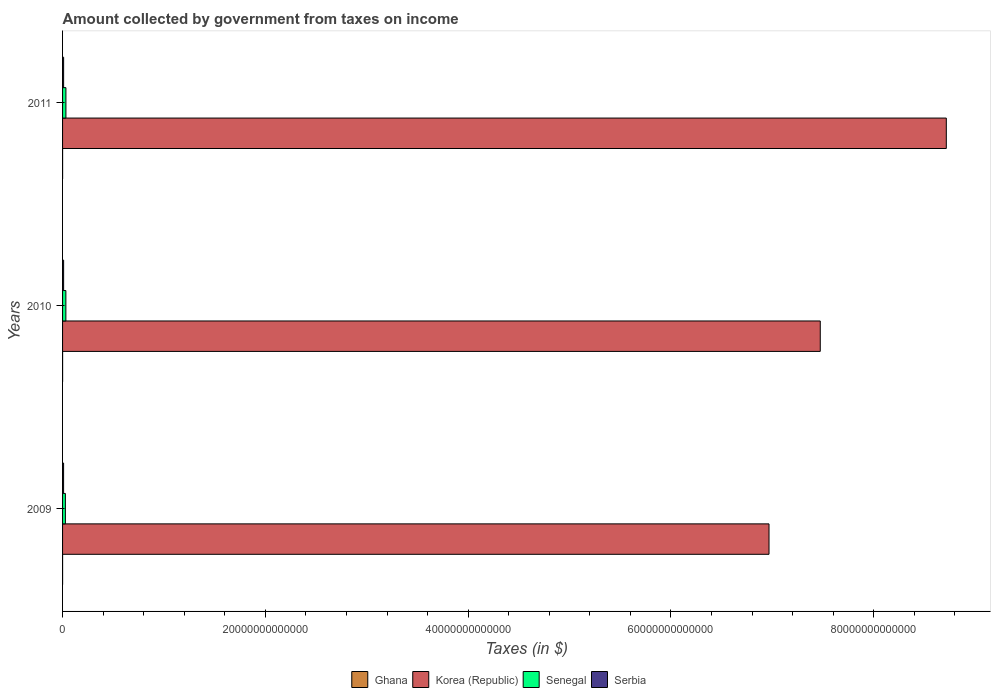How many different coloured bars are there?
Make the answer very short. 4. Are the number of bars per tick equal to the number of legend labels?
Offer a very short reply. Yes. How many bars are there on the 3rd tick from the bottom?
Give a very brief answer. 4. What is the label of the 3rd group of bars from the top?
Your answer should be compact. 2009. In how many cases, is the number of bars for a given year not equal to the number of legend labels?
Provide a short and direct response. 0. What is the amount collected by government from taxes on income in Korea (Republic) in 2010?
Keep it short and to the point. 7.47e+13. Across all years, what is the maximum amount collected by government from taxes on income in Serbia?
Provide a short and direct response. 1.05e+11. Across all years, what is the minimum amount collected by government from taxes on income in Korea (Republic)?
Give a very brief answer. 6.97e+13. What is the total amount collected by government from taxes on income in Ghana in the graph?
Your answer should be very brief. 6.93e+09. What is the difference between the amount collected by government from taxes on income in Ghana in 2010 and that in 2011?
Keep it short and to the point. -9.98e+08. What is the difference between the amount collected by government from taxes on income in Senegal in 2010 and the amount collected by government from taxes on income in Ghana in 2011?
Offer a very short reply. 3.23e+11. What is the average amount collected by government from taxes on income in Senegal per year?
Your response must be concise. 3.12e+11. In the year 2010, what is the difference between the amount collected by government from taxes on income in Ghana and amount collected by government from taxes on income in Serbia?
Offer a terse response. -1.03e+11. What is the ratio of the amount collected by government from taxes on income in Ghana in 2009 to that in 2011?
Your response must be concise. 0.48. Is the amount collected by government from taxes on income in Korea (Republic) in 2010 less than that in 2011?
Provide a succinct answer. Yes. Is the difference between the amount collected by government from taxes on income in Ghana in 2009 and 2011 greater than the difference between the amount collected by government from taxes on income in Serbia in 2009 and 2011?
Provide a succinct answer. Yes. What is the difference between the highest and the second highest amount collected by government from taxes on income in Senegal?
Provide a succinct answer. 4.64e+09. What is the difference between the highest and the lowest amount collected by government from taxes on income in Serbia?
Provide a succinct answer. 4.26e+09. In how many years, is the amount collected by government from taxes on income in Senegal greater than the average amount collected by government from taxes on income in Senegal taken over all years?
Provide a short and direct response. 2. Is it the case that in every year, the sum of the amount collected by government from taxes on income in Serbia and amount collected by government from taxes on income in Ghana is greater than the sum of amount collected by government from taxes on income in Korea (Republic) and amount collected by government from taxes on income in Senegal?
Your response must be concise. No. What does the 1st bar from the top in 2010 represents?
Keep it short and to the point. Serbia. What does the 2nd bar from the bottom in 2011 represents?
Your answer should be very brief. Korea (Republic). Is it the case that in every year, the sum of the amount collected by government from taxes on income in Senegal and amount collected by government from taxes on income in Serbia is greater than the amount collected by government from taxes on income in Korea (Republic)?
Provide a short and direct response. No. Are all the bars in the graph horizontal?
Your answer should be very brief. Yes. How many years are there in the graph?
Offer a terse response. 3. What is the difference between two consecutive major ticks on the X-axis?
Offer a terse response. 2.00e+13. Does the graph contain grids?
Make the answer very short. No. Where does the legend appear in the graph?
Provide a succinct answer. Bottom center. How many legend labels are there?
Make the answer very short. 4. How are the legend labels stacked?
Your answer should be very brief. Horizontal. What is the title of the graph?
Keep it short and to the point. Amount collected by government from taxes on income. Does "South Sudan" appear as one of the legend labels in the graph?
Your answer should be very brief. No. What is the label or title of the X-axis?
Give a very brief answer. Taxes (in $). What is the Taxes (in $) in Ghana in 2009?
Provide a short and direct response. 1.54e+09. What is the Taxes (in $) of Korea (Republic) in 2009?
Provide a succinct answer. 6.97e+13. What is the Taxes (in $) in Senegal in 2009?
Offer a terse response. 2.78e+11. What is the Taxes (in $) of Serbia in 2009?
Ensure brevity in your answer.  1.01e+11. What is the Taxes (in $) in Ghana in 2010?
Ensure brevity in your answer.  2.19e+09. What is the Taxes (in $) in Korea (Republic) in 2010?
Make the answer very short. 7.47e+13. What is the Taxes (in $) of Senegal in 2010?
Your answer should be very brief. 3.26e+11. What is the Taxes (in $) of Serbia in 2010?
Give a very brief answer. 1.05e+11. What is the Taxes (in $) in Ghana in 2011?
Provide a short and direct response. 3.19e+09. What is the Taxes (in $) of Korea (Republic) in 2011?
Provide a short and direct response. 8.72e+13. What is the Taxes (in $) in Senegal in 2011?
Your answer should be compact. 3.31e+11. What is the Taxes (in $) in Serbia in 2011?
Your answer should be very brief. 1.04e+11. Across all years, what is the maximum Taxes (in $) in Ghana?
Make the answer very short. 3.19e+09. Across all years, what is the maximum Taxes (in $) of Korea (Republic)?
Provide a succinct answer. 8.72e+13. Across all years, what is the maximum Taxes (in $) in Senegal?
Provide a succinct answer. 3.31e+11. Across all years, what is the maximum Taxes (in $) of Serbia?
Offer a very short reply. 1.05e+11. Across all years, what is the minimum Taxes (in $) of Ghana?
Keep it short and to the point. 1.54e+09. Across all years, what is the minimum Taxes (in $) of Korea (Republic)?
Your answer should be very brief. 6.97e+13. Across all years, what is the minimum Taxes (in $) of Senegal?
Offer a very short reply. 2.78e+11. Across all years, what is the minimum Taxes (in $) in Serbia?
Your answer should be compact. 1.01e+11. What is the total Taxes (in $) in Ghana in the graph?
Provide a short and direct response. 6.93e+09. What is the total Taxes (in $) of Korea (Republic) in the graph?
Offer a very short reply. 2.32e+14. What is the total Taxes (in $) in Senegal in the graph?
Your response must be concise. 9.36e+11. What is the total Taxes (in $) of Serbia in the graph?
Offer a terse response. 3.10e+11. What is the difference between the Taxes (in $) in Ghana in 2009 and that in 2010?
Keep it short and to the point. -6.57e+08. What is the difference between the Taxes (in $) in Korea (Republic) in 2009 and that in 2010?
Keep it short and to the point. -5.06e+12. What is the difference between the Taxes (in $) in Senegal in 2009 and that in 2010?
Your answer should be compact. -4.79e+1. What is the difference between the Taxes (in $) of Serbia in 2009 and that in 2010?
Your response must be concise. -4.26e+09. What is the difference between the Taxes (in $) in Ghana in 2009 and that in 2011?
Ensure brevity in your answer.  -1.65e+09. What is the difference between the Taxes (in $) of Korea (Republic) in 2009 and that in 2011?
Ensure brevity in your answer.  -1.75e+13. What is the difference between the Taxes (in $) of Senegal in 2009 and that in 2011?
Keep it short and to the point. -5.25e+1. What is the difference between the Taxes (in $) of Serbia in 2009 and that in 2011?
Offer a terse response. -3.69e+09. What is the difference between the Taxes (in $) in Ghana in 2010 and that in 2011?
Provide a short and direct response. -9.98e+08. What is the difference between the Taxes (in $) in Korea (Republic) in 2010 and that in 2011?
Your answer should be compact. -1.24e+13. What is the difference between the Taxes (in $) of Senegal in 2010 and that in 2011?
Keep it short and to the point. -4.64e+09. What is the difference between the Taxes (in $) in Serbia in 2010 and that in 2011?
Your answer should be very brief. 5.70e+08. What is the difference between the Taxes (in $) in Ghana in 2009 and the Taxes (in $) in Korea (Republic) in 2010?
Ensure brevity in your answer.  -7.47e+13. What is the difference between the Taxes (in $) of Ghana in 2009 and the Taxes (in $) of Senegal in 2010?
Make the answer very short. -3.25e+11. What is the difference between the Taxes (in $) in Ghana in 2009 and the Taxes (in $) in Serbia in 2010?
Offer a terse response. -1.04e+11. What is the difference between the Taxes (in $) in Korea (Republic) in 2009 and the Taxes (in $) in Senegal in 2010?
Provide a succinct answer. 6.93e+13. What is the difference between the Taxes (in $) of Korea (Republic) in 2009 and the Taxes (in $) of Serbia in 2010?
Your answer should be very brief. 6.96e+13. What is the difference between the Taxes (in $) in Senegal in 2009 and the Taxes (in $) in Serbia in 2010?
Your answer should be compact. 1.73e+11. What is the difference between the Taxes (in $) in Ghana in 2009 and the Taxes (in $) in Korea (Republic) in 2011?
Provide a succinct answer. -8.72e+13. What is the difference between the Taxes (in $) in Ghana in 2009 and the Taxes (in $) in Senegal in 2011?
Provide a short and direct response. -3.29e+11. What is the difference between the Taxes (in $) in Ghana in 2009 and the Taxes (in $) in Serbia in 2011?
Your answer should be very brief. -1.03e+11. What is the difference between the Taxes (in $) of Korea (Republic) in 2009 and the Taxes (in $) of Senegal in 2011?
Keep it short and to the point. 6.93e+13. What is the difference between the Taxes (in $) in Korea (Republic) in 2009 and the Taxes (in $) in Serbia in 2011?
Ensure brevity in your answer.  6.96e+13. What is the difference between the Taxes (in $) of Senegal in 2009 and the Taxes (in $) of Serbia in 2011?
Make the answer very short. 1.74e+11. What is the difference between the Taxes (in $) of Ghana in 2010 and the Taxes (in $) of Korea (Republic) in 2011?
Your response must be concise. -8.72e+13. What is the difference between the Taxes (in $) in Ghana in 2010 and the Taxes (in $) in Senegal in 2011?
Your answer should be very brief. -3.29e+11. What is the difference between the Taxes (in $) of Ghana in 2010 and the Taxes (in $) of Serbia in 2011?
Your answer should be very brief. -1.02e+11. What is the difference between the Taxes (in $) of Korea (Republic) in 2010 and the Taxes (in $) of Senegal in 2011?
Make the answer very short. 7.44e+13. What is the difference between the Taxes (in $) in Korea (Republic) in 2010 and the Taxes (in $) in Serbia in 2011?
Provide a short and direct response. 7.46e+13. What is the difference between the Taxes (in $) of Senegal in 2010 and the Taxes (in $) of Serbia in 2011?
Your response must be concise. 2.22e+11. What is the average Taxes (in $) of Ghana per year?
Give a very brief answer. 2.31e+09. What is the average Taxes (in $) of Korea (Republic) per year?
Provide a succinct answer. 7.72e+13. What is the average Taxes (in $) in Senegal per year?
Your answer should be compact. 3.12e+11. What is the average Taxes (in $) of Serbia per year?
Keep it short and to the point. 1.03e+11. In the year 2009, what is the difference between the Taxes (in $) in Ghana and Taxes (in $) in Korea (Republic)?
Provide a succinct answer. -6.97e+13. In the year 2009, what is the difference between the Taxes (in $) of Ghana and Taxes (in $) of Senegal?
Your answer should be very brief. -2.77e+11. In the year 2009, what is the difference between the Taxes (in $) in Ghana and Taxes (in $) in Serbia?
Your answer should be compact. -9.93e+1. In the year 2009, what is the difference between the Taxes (in $) of Korea (Republic) and Taxes (in $) of Senegal?
Give a very brief answer. 6.94e+13. In the year 2009, what is the difference between the Taxes (in $) in Korea (Republic) and Taxes (in $) in Serbia?
Your answer should be very brief. 6.96e+13. In the year 2009, what is the difference between the Taxes (in $) in Senegal and Taxes (in $) in Serbia?
Your response must be concise. 1.78e+11. In the year 2010, what is the difference between the Taxes (in $) in Ghana and Taxes (in $) in Korea (Republic)?
Provide a succinct answer. -7.47e+13. In the year 2010, what is the difference between the Taxes (in $) in Ghana and Taxes (in $) in Senegal?
Give a very brief answer. -3.24e+11. In the year 2010, what is the difference between the Taxes (in $) of Ghana and Taxes (in $) of Serbia?
Offer a very short reply. -1.03e+11. In the year 2010, what is the difference between the Taxes (in $) in Korea (Republic) and Taxes (in $) in Senegal?
Ensure brevity in your answer.  7.44e+13. In the year 2010, what is the difference between the Taxes (in $) of Korea (Republic) and Taxes (in $) of Serbia?
Your answer should be compact. 7.46e+13. In the year 2010, what is the difference between the Taxes (in $) of Senegal and Taxes (in $) of Serbia?
Ensure brevity in your answer.  2.21e+11. In the year 2011, what is the difference between the Taxes (in $) in Ghana and Taxes (in $) in Korea (Republic)?
Ensure brevity in your answer.  -8.72e+13. In the year 2011, what is the difference between the Taxes (in $) of Ghana and Taxes (in $) of Senegal?
Offer a terse response. -3.28e+11. In the year 2011, what is the difference between the Taxes (in $) of Ghana and Taxes (in $) of Serbia?
Offer a terse response. -1.01e+11. In the year 2011, what is the difference between the Taxes (in $) of Korea (Republic) and Taxes (in $) of Senegal?
Your response must be concise. 8.68e+13. In the year 2011, what is the difference between the Taxes (in $) of Korea (Republic) and Taxes (in $) of Serbia?
Provide a short and direct response. 8.71e+13. In the year 2011, what is the difference between the Taxes (in $) in Senegal and Taxes (in $) in Serbia?
Your answer should be very brief. 2.26e+11. What is the ratio of the Taxes (in $) in Ghana in 2009 to that in 2010?
Keep it short and to the point. 0.7. What is the ratio of the Taxes (in $) of Korea (Republic) in 2009 to that in 2010?
Give a very brief answer. 0.93. What is the ratio of the Taxes (in $) of Senegal in 2009 to that in 2010?
Ensure brevity in your answer.  0.85. What is the ratio of the Taxes (in $) in Serbia in 2009 to that in 2010?
Provide a succinct answer. 0.96. What is the ratio of the Taxes (in $) of Ghana in 2009 to that in 2011?
Offer a terse response. 0.48. What is the ratio of the Taxes (in $) of Korea (Republic) in 2009 to that in 2011?
Provide a succinct answer. 0.8. What is the ratio of the Taxes (in $) in Senegal in 2009 to that in 2011?
Your answer should be compact. 0.84. What is the ratio of the Taxes (in $) in Serbia in 2009 to that in 2011?
Offer a terse response. 0.96. What is the ratio of the Taxes (in $) of Ghana in 2010 to that in 2011?
Provide a short and direct response. 0.69. What is the ratio of the Taxes (in $) of Korea (Republic) in 2010 to that in 2011?
Provide a short and direct response. 0.86. What is the ratio of the Taxes (in $) in Senegal in 2010 to that in 2011?
Give a very brief answer. 0.99. What is the ratio of the Taxes (in $) in Serbia in 2010 to that in 2011?
Keep it short and to the point. 1.01. What is the difference between the highest and the second highest Taxes (in $) of Ghana?
Your response must be concise. 9.98e+08. What is the difference between the highest and the second highest Taxes (in $) of Korea (Republic)?
Provide a short and direct response. 1.24e+13. What is the difference between the highest and the second highest Taxes (in $) of Senegal?
Ensure brevity in your answer.  4.64e+09. What is the difference between the highest and the second highest Taxes (in $) of Serbia?
Your answer should be compact. 5.70e+08. What is the difference between the highest and the lowest Taxes (in $) of Ghana?
Make the answer very short. 1.65e+09. What is the difference between the highest and the lowest Taxes (in $) in Korea (Republic)?
Your response must be concise. 1.75e+13. What is the difference between the highest and the lowest Taxes (in $) in Senegal?
Give a very brief answer. 5.25e+1. What is the difference between the highest and the lowest Taxes (in $) in Serbia?
Your answer should be very brief. 4.26e+09. 